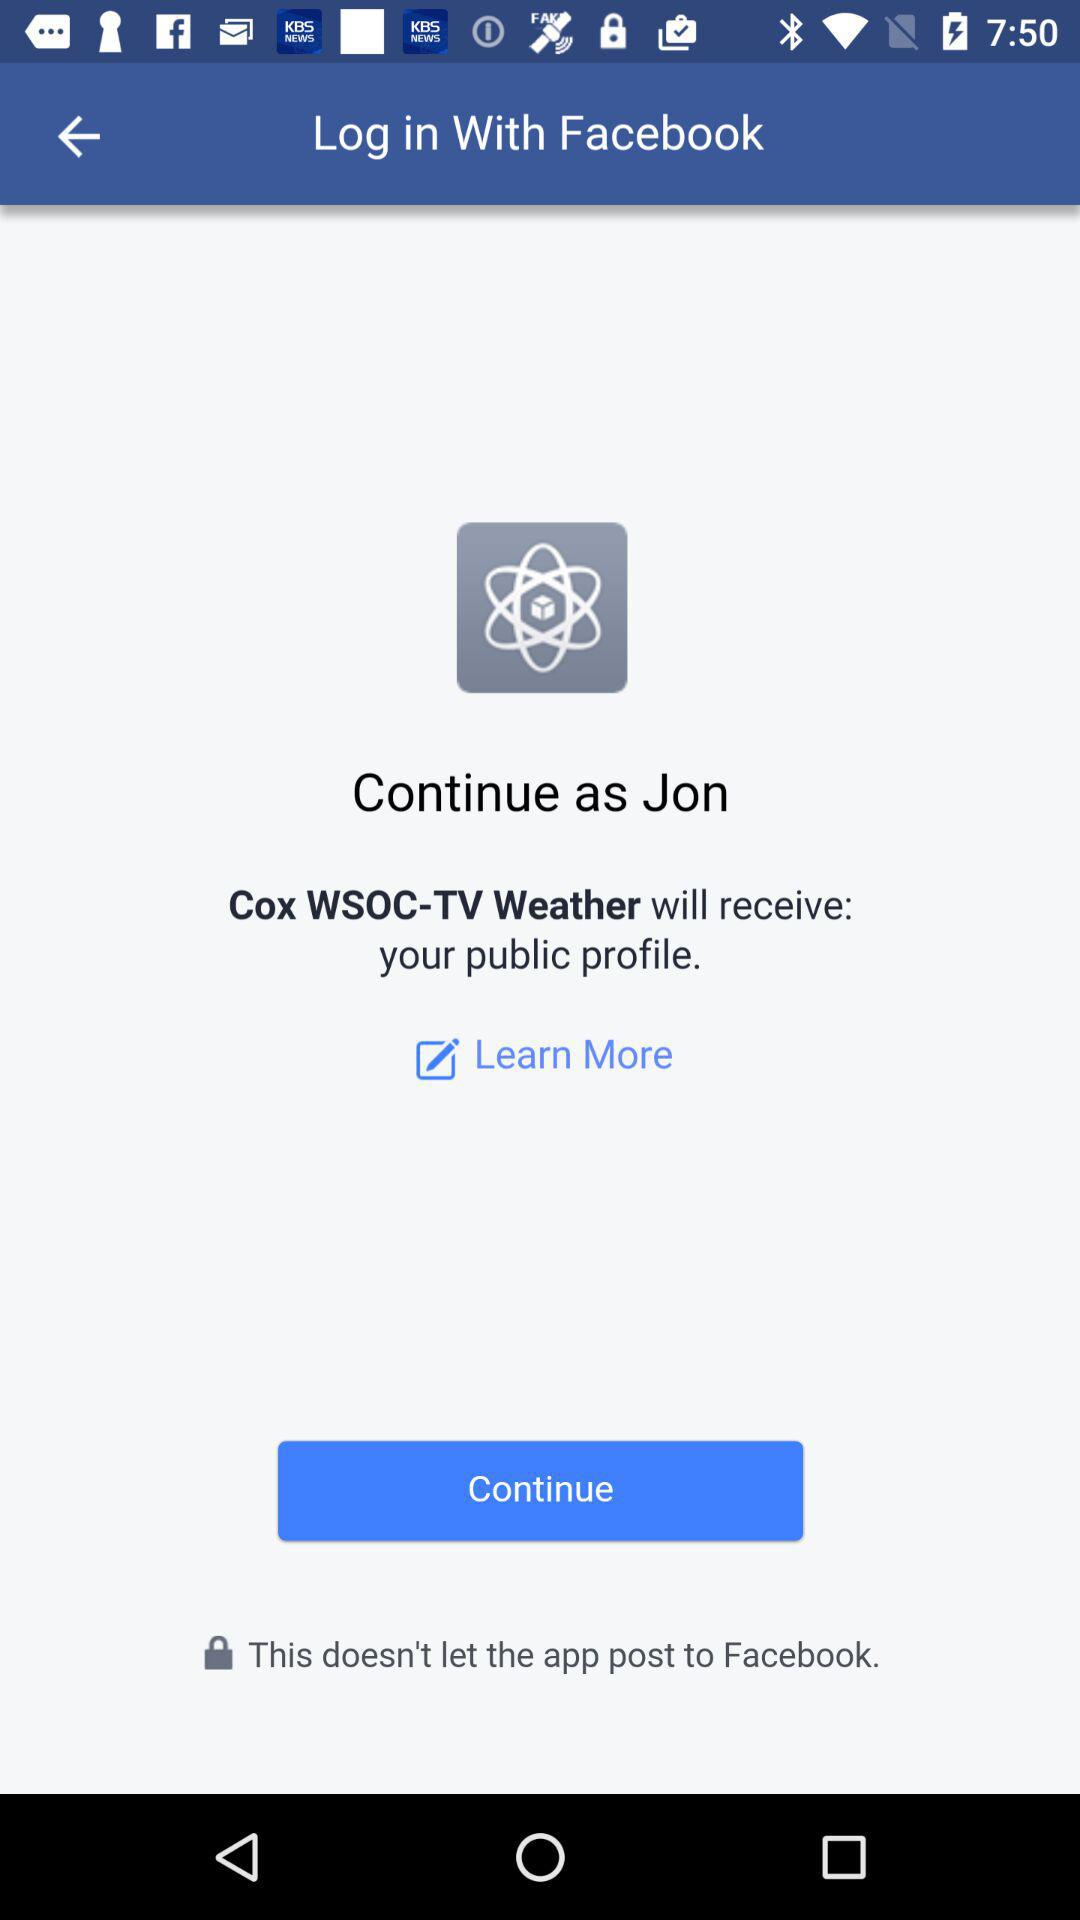What application is the user accessing? The user is accessing "Cox WSOC-TV Weather". 